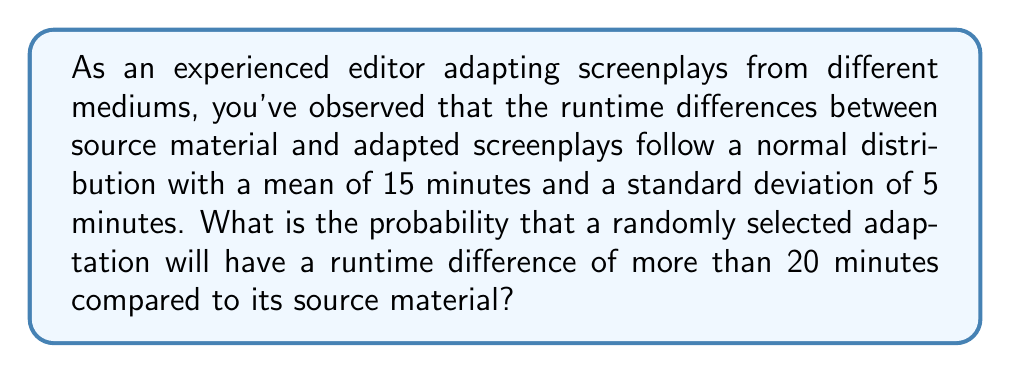Help me with this question. To solve this problem, we need to follow these steps:

1. Identify the given information:
   - The runtime differences follow a normal distribution
   - Mean (μ) = 15 minutes
   - Standard deviation (σ) = 5 minutes
   - We want to find P(X > 20), where X is the runtime difference

2. Calculate the z-score for the given value:
   $$ z = \frac{x - \mu}{\sigma} = \frac{20 - 15}{5} = 1 $$

3. Use the standard normal distribution table or a calculator to find the area to the right of z = 1:
   P(Z > 1) = 1 - P(Z < 1) = 1 - 0.8413 = 0.1587

4. Therefore, the probability that a randomly selected adaptation will have a runtime difference of more than 20 minutes is approximately 0.1587 or 15.87%.

This calculation assumes that the runtime differences are normally distributed and that the given mean and standard deviation accurately represent the population parameters.
Answer: 0.1587 